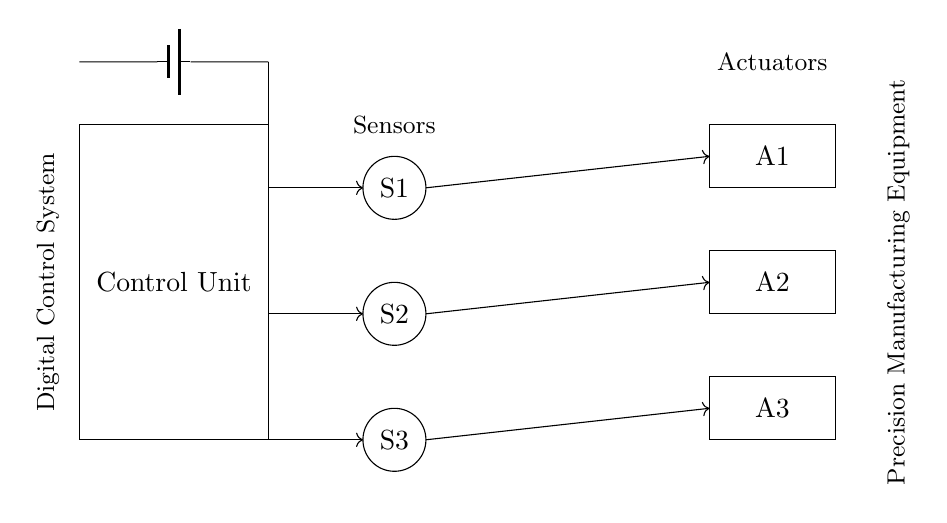What are the components shown in this circuit? The circuit includes a control unit, three sensors (S1, S2, S3), three actuators (A1, A2, A3), and a power supply (battery). Each component is represented visually, and their labels provide clear identification.
Answer: Control unit, sensors, actuators, battery How many sensors are in this circuit? There are a total of three sensors labeled as S1, S2, and S3 in the circuit diagram. The diagram explicitly shows all sensor components along with their labels.
Answer: Three What does the arrow represent in the connections? The arrows in the connections indicate the direction of signal flow from the control unit to the sensors and actuators. This illustrates that the control unit sends commands or data to the other components.
Answer: Direction of signal flow What type of control system is represented in this circuit? The circuit represents a digital control system as indicated by the label "Digital Control System" next to the control unit. This suggests that the system processes digital signals for precision manufacturing.
Answer: Digital control system Which actuator is at the highest position in the circuit? The actuator labeled A1 is positioned at the highest point in the circuit diagram. This can be determined by observing the vertical arrangement of the component labels, where A1 is above A2 and A3.
Answer: A1 What is the function of the power supply in this circuit diagram? The power supply provides the necessary voltage and current to operate the control unit, sensors, and actuators. Its presence is essential for the circuit to function as it offers the energy needed for the entire digital control system.
Answer: Power supply for energy 